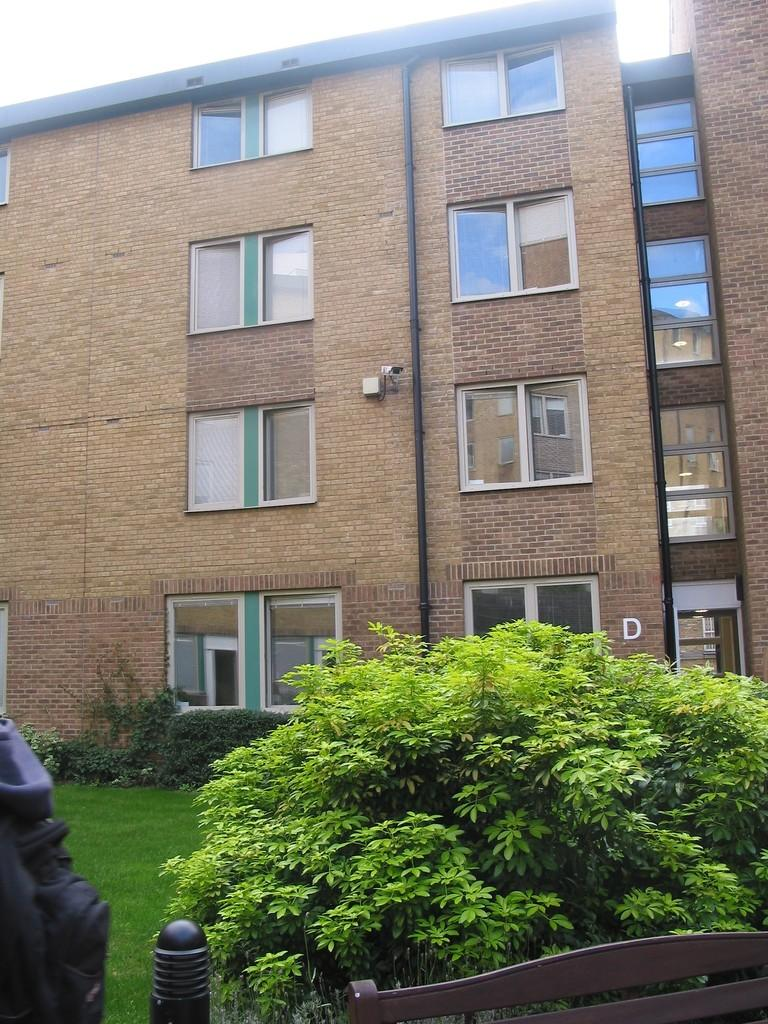What type of structure is present in the image? There is a building in the image. What feature of the building is mentioned in the facts? The building has many windows. What can be seen in front of the building? There are trees and plants in front of the building. Where are the trees and plants located? The trees and plants are on a grassland. What part of the natural environment is visible in the image? The sky is visible above the building. What type of metal is used to make the lead in the image? There is no lead or metal present in the image. 